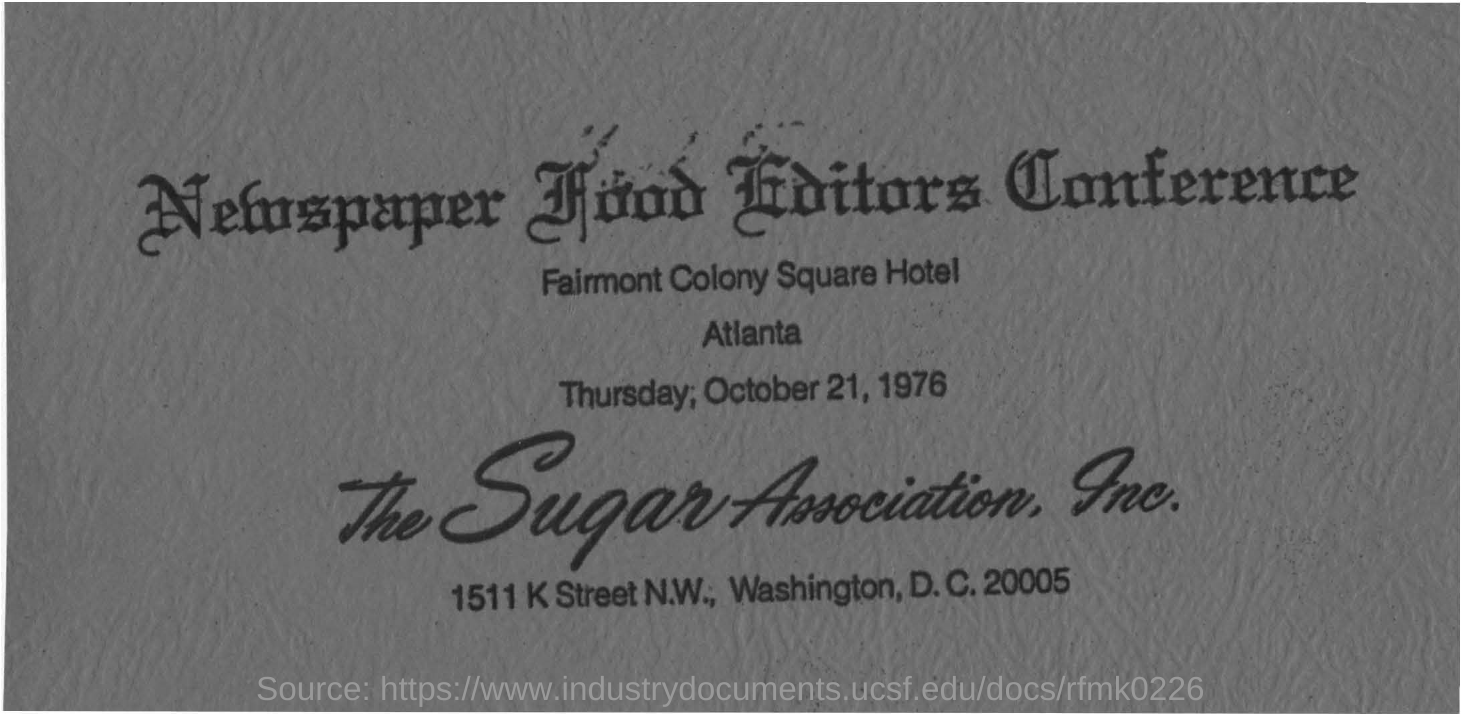What is the name of the conference ?
Offer a very short reply. Newspaper food editors conference. In which hotel is  this conference held ?
Offer a terse response. Fairmont colony square hotel. On which date this conference was held ?
Provide a succinct answer. Thursday, october 21, 1976. 